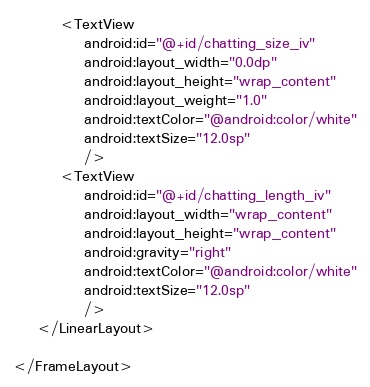<code> <loc_0><loc_0><loc_500><loc_500><_XML_>	    <TextView 
	        android:id="@+id/chatting_size_iv"
	        android:layout_width="0.0dp"
	        android:layout_height="wrap_content"
	        android:layout_weight="1.0"
	        android:textColor="@android:color/white"
	        android:textSize="12.0sp"
	        />
	    <TextView 
	        android:id="@+id/chatting_length_iv"
	        android:layout_width="wrap_content"
	        android:layout_height="wrap_content"
	        android:gravity="right"
	        android:textColor="@android:color/white"
	        android:textSize="12.0sp"
	        />
	</LinearLayout>
     
</FrameLayout>
</code> 